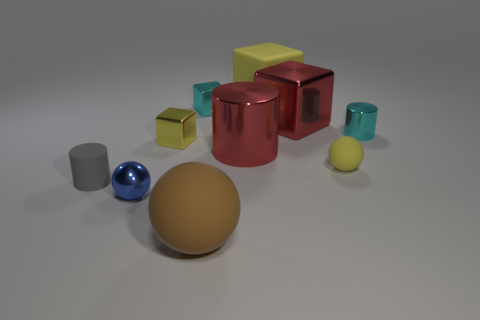What is the material of the large block that is on the left side of the red metallic block?
Your response must be concise. Rubber. There is a cyan metal object to the right of the tiny cyan shiny cube; is its size the same as the thing that is in front of the small blue shiny ball?
Offer a terse response. No. The large metallic block has what color?
Provide a short and direct response. Red. Is the shape of the small matte object on the right side of the large brown matte object the same as  the tiny gray thing?
Your response must be concise. No. What is the material of the red cylinder?
Provide a succinct answer. Metal. What shape is the gray object that is the same size as the cyan cylinder?
Make the answer very short. Cylinder. Is there a tiny metal cylinder of the same color as the big cylinder?
Your response must be concise. No. There is a tiny matte cylinder; does it have the same color as the small cube to the left of the cyan block?
Keep it short and to the point. No. What is the color of the shiny cylinder to the left of the tiny matte object to the right of the blue object?
Ensure brevity in your answer.  Red. There is a small sphere that is behind the tiny blue shiny ball left of the large red shiny cylinder; are there any blue metal objects that are behind it?
Keep it short and to the point. No. 